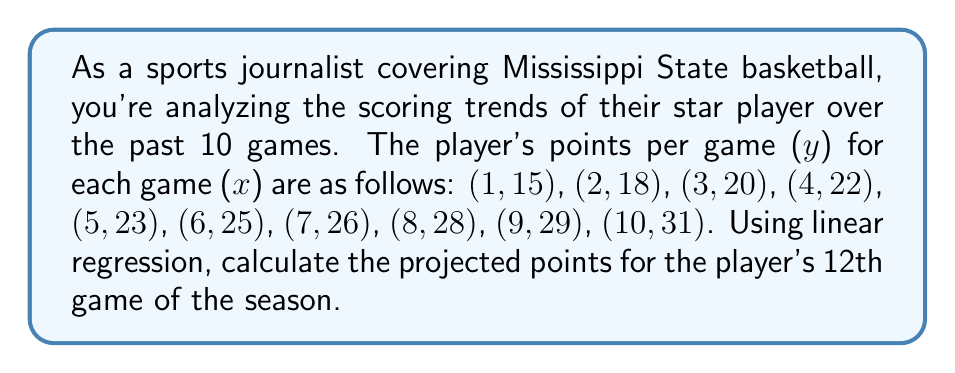Give your solution to this math problem. To solve this problem, we'll use linear regression to find the line of best fit and then use it to predict the player's points for the 12th game. Let's follow these steps:

1. Calculate the means of x and y:
   $\bar{x} = \frac{1+2+3+4+5+6+7+8+9+10}{10} = 5.5$
   $\bar{y} = \frac{15+18+20+22+23+25+26+28+29+31}{10} = 23.7$

2. Calculate the slope (m) using the formula:
   $m = \frac{\sum(x_i - \bar{x})(y_i - \bar{y})}{\sum(x_i - \bar{x})^2}$

   $\sum(x_i - \bar{x})(y_i - \bar{y}) = 165.5$
   $\sum(x_i - \bar{x})^2 = 82.5$

   $m = \frac{165.5}{82.5} = 2$

3. Find the y-intercept (b) using the point-slope form:
   $\bar{y} = m\bar{x} + b$
   $23.7 = 2(5.5) + b$
   $b = 23.7 - 11 = 12.7$

4. The equation of the line is:
   $y = 2x + 12.7$

5. To predict the points for the 12th game, substitute x = 12:
   $y = 2(12) + 12.7 = 36.7$

Therefore, the projected points for the player's 12th game is approximately 36.7 points.
Answer: 36.7 points 